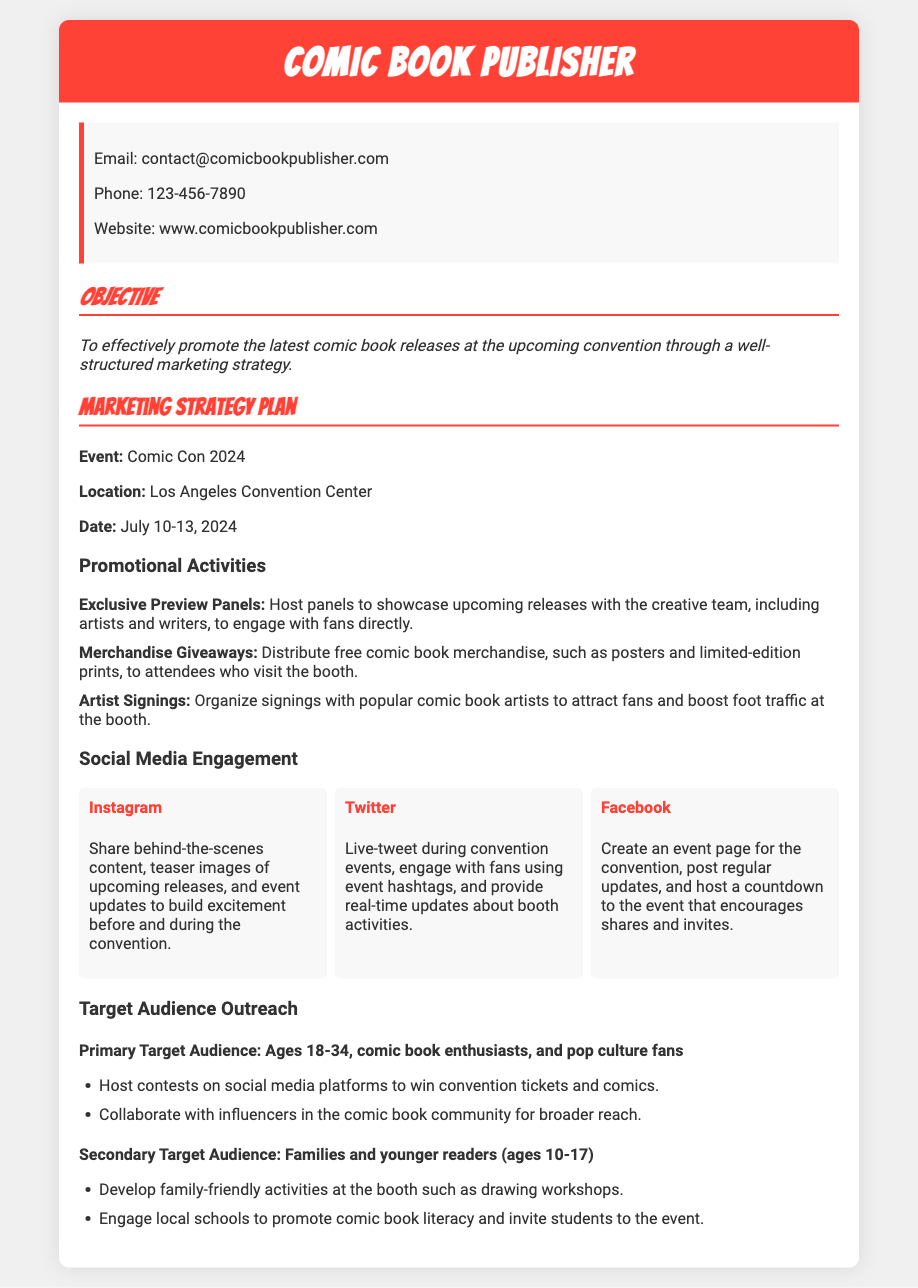What is the event name? The document states the event name as Comic Con 2024.
Answer: Comic Con 2024 When will the convention take place? The document specifies the convention dates as July 10-13, 2024.
Answer: July 10-13, 2024 What is one promotional activity mentioned? A promotional activity listed is Exclusive Preview Panels during the convention.
Answer: Exclusive Preview Panels Which social media platform is used for live-tweeting? The document indicates that Twitter is the platform for live-tweeting during events.
Answer: Twitter What is the age range of the primary target audience? The document specifies the primary target audience age range as 18-34.
Answer: 18-34 What type of audience does the document define as secondary? The document describes the secondary target audience as families and younger readers.
Answer: Families and younger readers What merchandise is mentioned for giveaways? The document mentions free comic book merchandise such as posters.
Answer: Posters How will the booth engage younger readers? The document states the booth will have drawing workshops for engagement.
Answer: Drawing workshops What is the purpose of creating an event page on Facebook? The document outlines that the event page is meant for posting regular updates about the convention.
Answer: Posting regular updates 